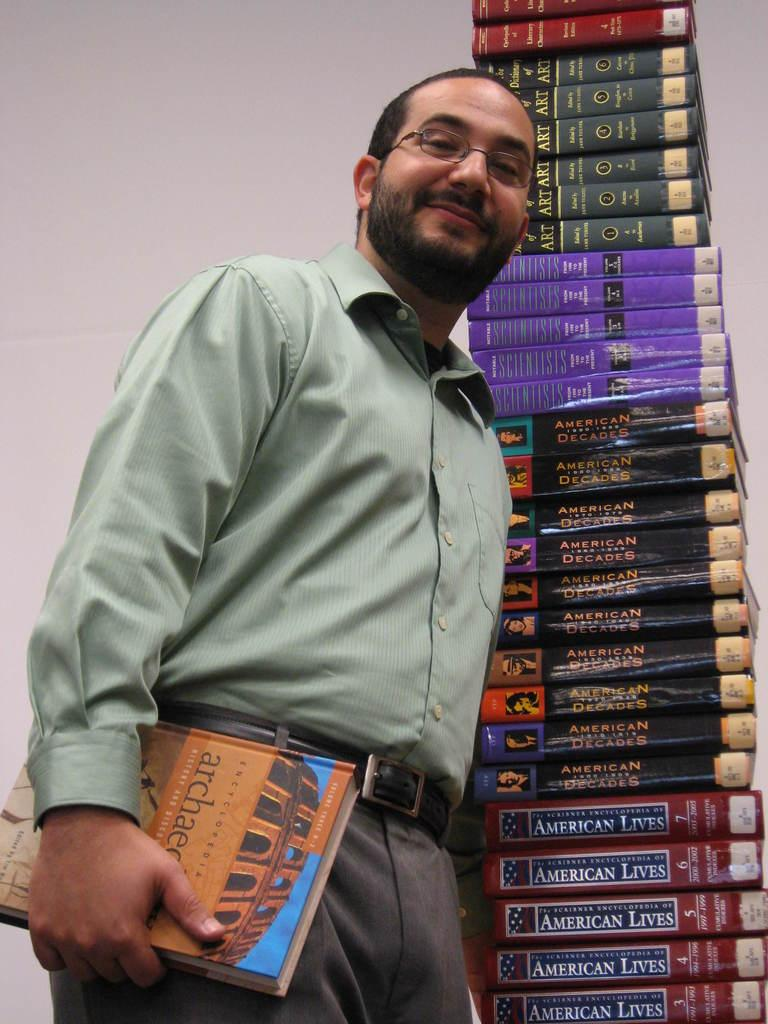Provide a one-sentence caption for the provided image. A smiling man holds a book on architecture while he stands next to a tall pile of textbooks. 